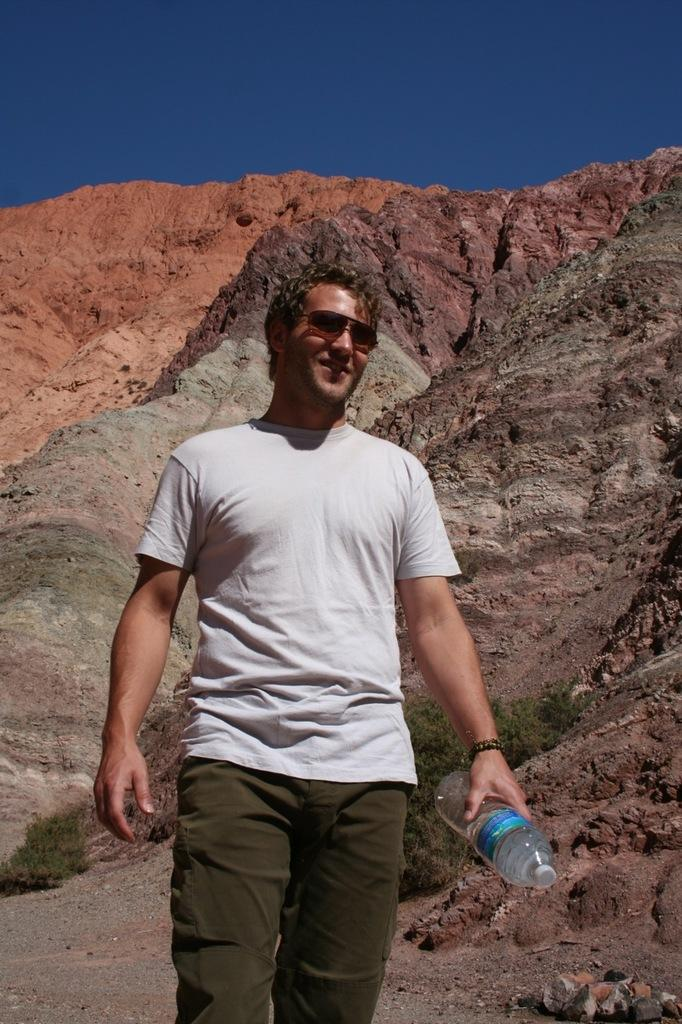Who is present in the image? There is a man in the picture. What is the man wearing on his face? The man is wearing sunglasses. What is the man holding in his hand? The man is holding a bottle in his hand. What can be seen in the distance in the image? There are hills visible in the background of the picture. What color is the sky in the image? The sky is blue in the picture. What type of shoe is the man wearing in the image? The image does not show the man's shoes, so it is not possible to determine what type of shoe he is wearing. 